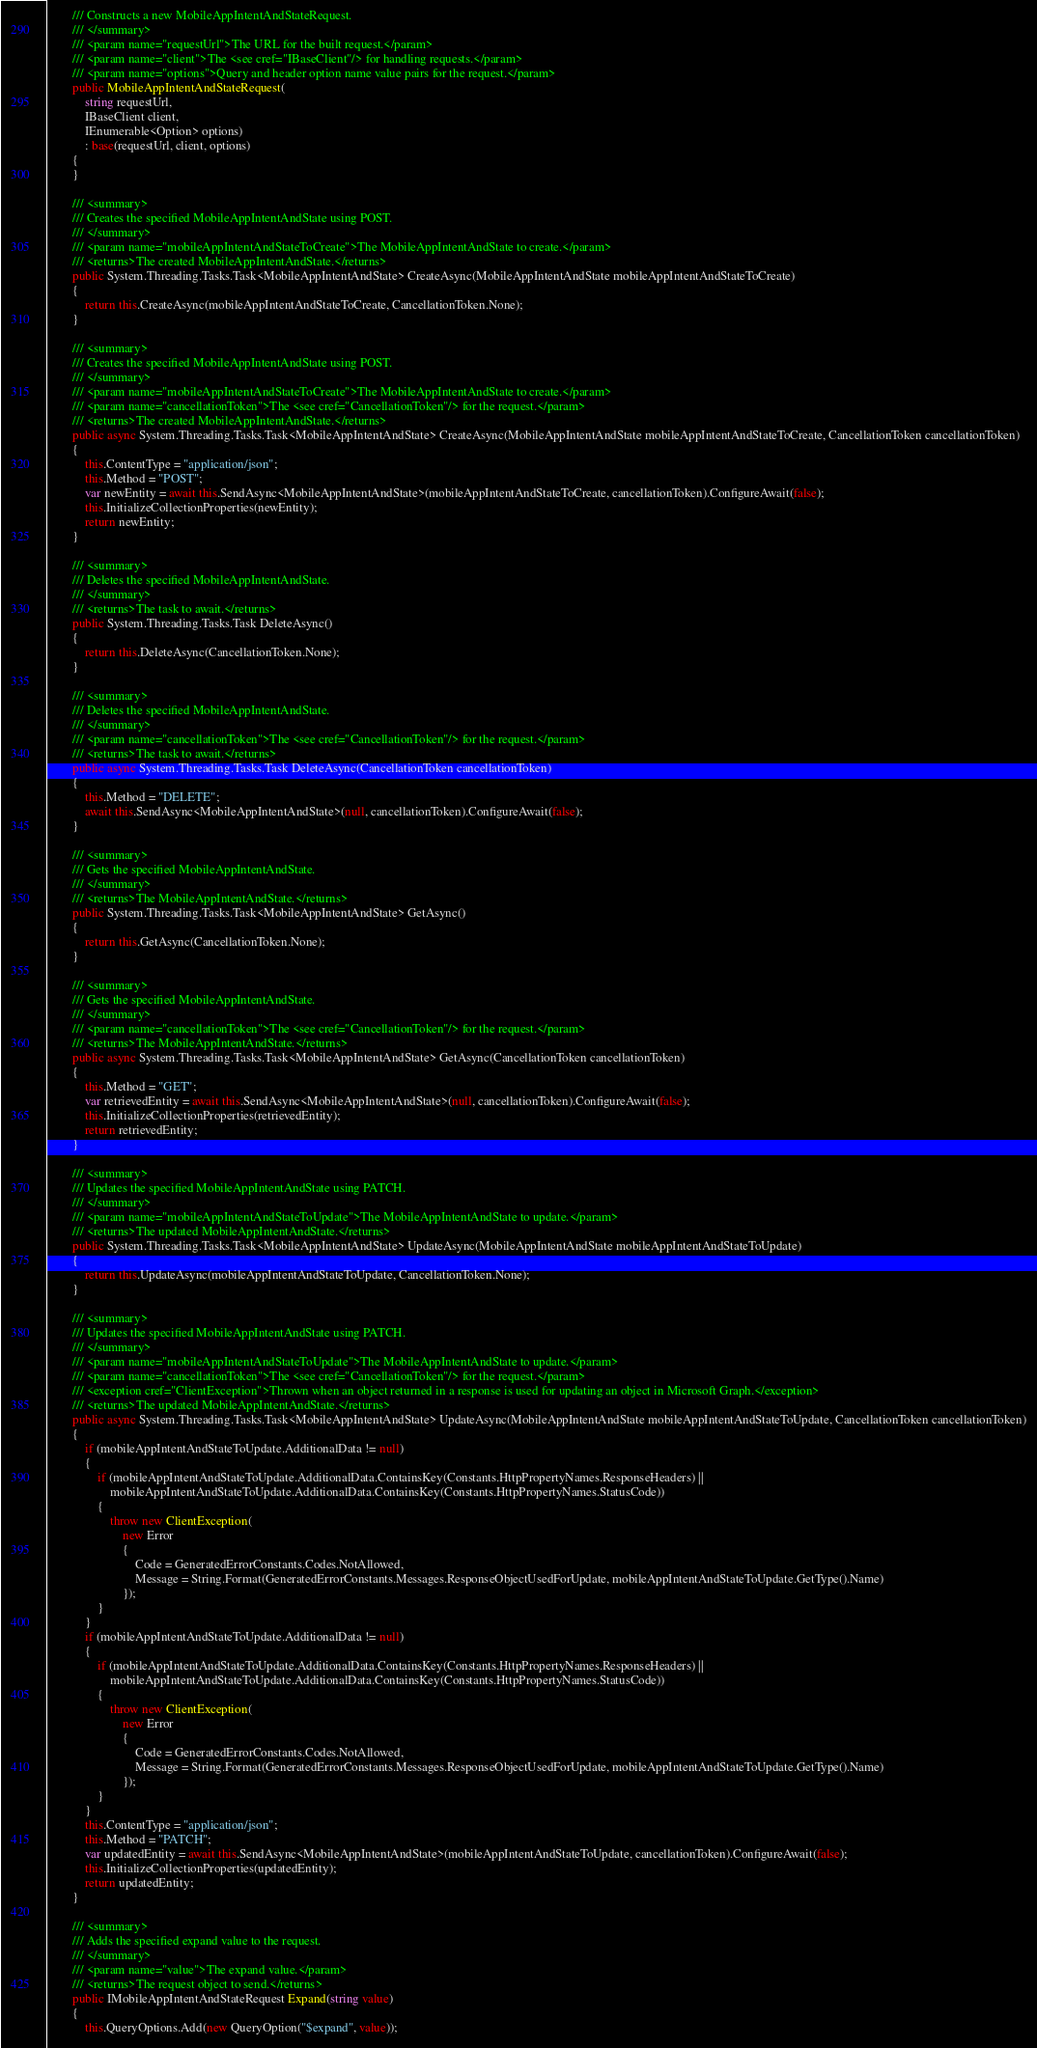Convert code to text. <code><loc_0><loc_0><loc_500><loc_500><_C#_>        /// Constructs a new MobileAppIntentAndStateRequest.
        /// </summary>
        /// <param name="requestUrl">The URL for the built request.</param>
        /// <param name="client">The <see cref="IBaseClient"/> for handling requests.</param>
        /// <param name="options">Query and header option name value pairs for the request.</param>
        public MobileAppIntentAndStateRequest(
            string requestUrl,
            IBaseClient client,
            IEnumerable<Option> options)
            : base(requestUrl, client, options)
        {
        }

        /// <summary>
        /// Creates the specified MobileAppIntentAndState using POST.
        /// </summary>
        /// <param name="mobileAppIntentAndStateToCreate">The MobileAppIntentAndState to create.</param>
        /// <returns>The created MobileAppIntentAndState.</returns>
        public System.Threading.Tasks.Task<MobileAppIntentAndState> CreateAsync(MobileAppIntentAndState mobileAppIntentAndStateToCreate)
        {
            return this.CreateAsync(mobileAppIntentAndStateToCreate, CancellationToken.None);
        }

        /// <summary>
        /// Creates the specified MobileAppIntentAndState using POST.
        /// </summary>
        /// <param name="mobileAppIntentAndStateToCreate">The MobileAppIntentAndState to create.</param>
        /// <param name="cancellationToken">The <see cref="CancellationToken"/> for the request.</param>
        /// <returns>The created MobileAppIntentAndState.</returns>
        public async System.Threading.Tasks.Task<MobileAppIntentAndState> CreateAsync(MobileAppIntentAndState mobileAppIntentAndStateToCreate, CancellationToken cancellationToken)
        {
            this.ContentType = "application/json";
            this.Method = "POST";
            var newEntity = await this.SendAsync<MobileAppIntentAndState>(mobileAppIntentAndStateToCreate, cancellationToken).ConfigureAwait(false);
            this.InitializeCollectionProperties(newEntity);
            return newEntity;
        }

        /// <summary>
        /// Deletes the specified MobileAppIntentAndState.
        /// </summary>
        /// <returns>The task to await.</returns>
        public System.Threading.Tasks.Task DeleteAsync()
        {
            return this.DeleteAsync(CancellationToken.None);
        }

        /// <summary>
        /// Deletes the specified MobileAppIntentAndState.
        /// </summary>
        /// <param name="cancellationToken">The <see cref="CancellationToken"/> for the request.</param>
        /// <returns>The task to await.</returns>
        public async System.Threading.Tasks.Task DeleteAsync(CancellationToken cancellationToken)
        {
            this.Method = "DELETE";
            await this.SendAsync<MobileAppIntentAndState>(null, cancellationToken).ConfigureAwait(false);
        }

        /// <summary>
        /// Gets the specified MobileAppIntentAndState.
        /// </summary>
        /// <returns>The MobileAppIntentAndState.</returns>
        public System.Threading.Tasks.Task<MobileAppIntentAndState> GetAsync()
        {
            return this.GetAsync(CancellationToken.None);
        }

        /// <summary>
        /// Gets the specified MobileAppIntentAndState.
        /// </summary>
        /// <param name="cancellationToken">The <see cref="CancellationToken"/> for the request.</param>
        /// <returns>The MobileAppIntentAndState.</returns>
        public async System.Threading.Tasks.Task<MobileAppIntentAndState> GetAsync(CancellationToken cancellationToken)
        {
            this.Method = "GET";
            var retrievedEntity = await this.SendAsync<MobileAppIntentAndState>(null, cancellationToken).ConfigureAwait(false);
            this.InitializeCollectionProperties(retrievedEntity);
            return retrievedEntity;
        }

        /// <summary>
        /// Updates the specified MobileAppIntentAndState using PATCH.
        /// </summary>
        /// <param name="mobileAppIntentAndStateToUpdate">The MobileAppIntentAndState to update.</param>
        /// <returns>The updated MobileAppIntentAndState.</returns>
        public System.Threading.Tasks.Task<MobileAppIntentAndState> UpdateAsync(MobileAppIntentAndState mobileAppIntentAndStateToUpdate)
        {
            return this.UpdateAsync(mobileAppIntentAndStateToUpdate, CancellationToken.None);
        }

        /// <summary>
        /// Updates the specified MobileAppIntentAndState using PATCH.
        /// </summary>
        /// <param name="mobileAppIntentAndStateToUpdate">The MobileAppIntentAndState to update.</param>
        /// <param name="cancellationToken">The <see cref="CancellationToken"/> for the request.</param>
        /// <exception cref="ClientException">Thrown when an object returned in a response is used for updating an object in Microsoft Graph.</exception>
        /// <returns>The updated MobileAppIntentAndState.</returns>
        public async System.Threading.Tasks.Task<MobileAppIntentAndState> UpdateAsync(MobileAppIntentAndState mobileAppIntentAndStateToUpdate, CancellationToken cancellationToken)
        {
			if (mobileAppIntentAndStateToUpdate.AdditionalData != null)
			{
				if (mobileAppIntentAndStateToUpdate.AdditionalData.ContainsKey(Constants.HttpPropertyNames.ResponseHeaders) ||
					mobileAppIntentAndStateToUpdate.AdditionalData.ContainsKey(Constants.HttpPropertyNames.StatusCode))
				{
					throw new ClientException(
						new Error
						{
							Code = GeneratedErrorConstants.Codes.NotAllowed,
							Message = String.Format(GeneratedErrorConstants.Messages.ResponseObjectUsedForUpdate, mobileAppIntentAndStateToUpdate.GetType().Name)
						});
				}
			}
            if (mobileAppIntentAndStateToUpdate.AdditionalData != null)
            {
                if (mobileAppIntentAndStateToUpdate.AdditionalData.ContainsKey(Constants.HttpPropertyNames.ResponseHeaders) ||
                    mobileAppIntentAndStateToUpdate.AdditionalData.ContainsKey(Constants.HttpPropertyNames.StatusCode))
                {
                    throw new ClientException(
                        new Error
                        {
                            Code = GeneratedErrorConstants.Codes.NotAllowed,
                            Message = String.Format(GeneratedErrorConstants.Messages.ResponseObjectUsedForUpdate, mobileAppIntentAndStateToUpdate.GetType().Name)
                        });
                }
            }
            this.ContentType = "application/json";
            this.Method = "PATCH";
            var updatedEntity = await this.SendAsync<MobileAppIntentAndState>(mobileAppIntentAndStateToUpdate, cancellationToken).ConfigureAwait(false);
            this.InitializeCollectionProperties(updatedEntity);
            return updatedEntity;
        }

        /// <summary>
        /// Adds the specified expand value to the request.
        /// </summary>
        /// <param name="value">The expand value.</param>
        /// <returns>The request object to send.</returns>
        public IMobileAppIntentAndStateRequest Expand(string value)
        {
            this.QueryOptions.Add(new QueryOption("$expand", value));</code> 